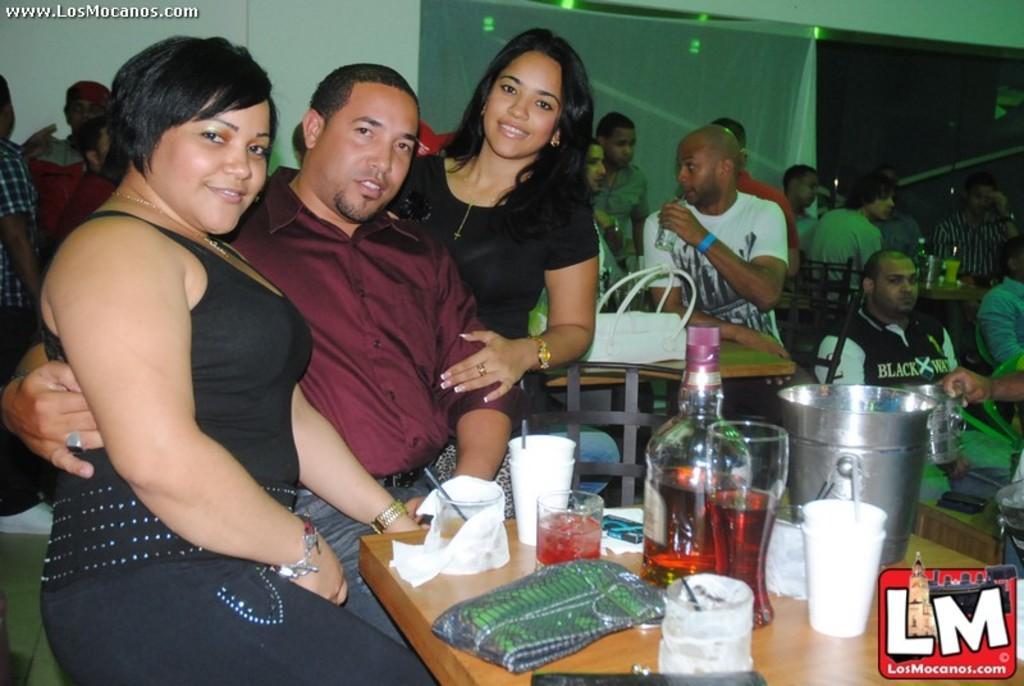How would you summarize this image in a sentence or two? There are cups, glasses and a bottle is kept on a surface as we can see at the bottom of this image. We can see people in the middle of this image and there are chairs on the right side of this image. There is a wall and a curtain in the background. There is a logo in the bottom right corner of this image and in the top left corner of this image. 